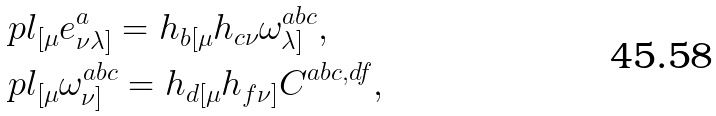Convert formula to latex. <formula><loc_0><loc_0><loc_500><loc_500>& \ p l _ { [ \mu } e ^ { a } _ { \nu \lambda ] } = h _ { b [ \mu } h _ { c \nu } \omega ^ { a b c } _ { \lambda ] } , \\ & \ p l _ { [ \mu } \omega ^ { a b c } _ { \nu ] } = h _ { d [ \mu } h _ { f \nu ] } C ^ { a b c , d f } ,</formula> 